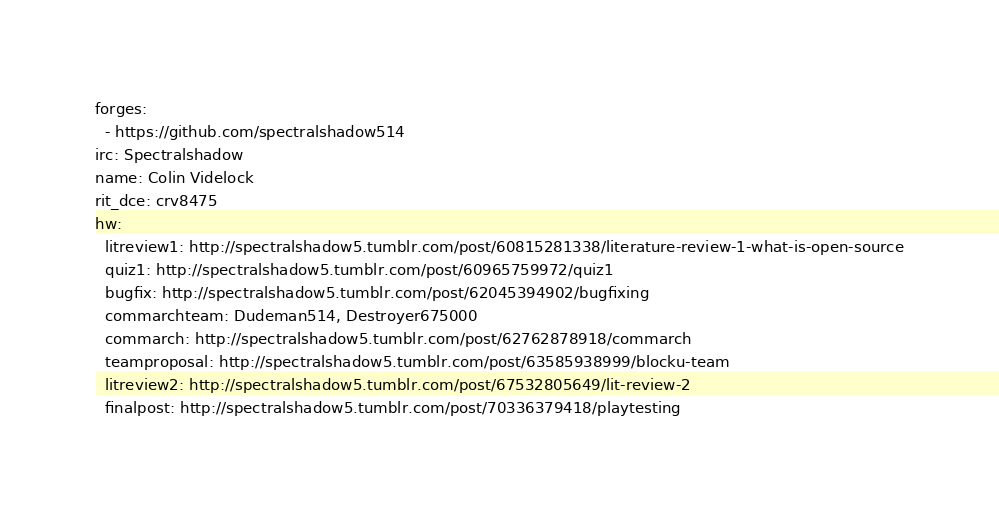<code> <loc_0><loc_0><loc_500><loc_500><_YAML_>forges:
  - https://github.com/spectralshadow514
irc: Spectralshadow
name: Colin Videlock
rit_dce: crv8475
hw:
  litreview1: http://spectralshadow5.tumblr.com/post/60815281338/literature-review-1-what-is-open-source
  quiz1: http://spectralshadow5.tumblr.com/post/60965759972/quiz1
  bugfix: http://spectralshadow5.tumblr.com/post/62045394902/bugfixing
  commarchteam: Dudeman514, Destroyer675000
  commarch: http://spectralshadow5.tumblr.com/post/62762878918/commarch
  teamproposal: http://spectralshadow5.tumblr.com/post/63585938999/blocku-team
  litreview2: http://spectralshadow5.tumblr.com/post/67532805649/lit-review-2
  finalpost: http://spectralshadow5.tumblr.com/post/70336379418/playtesting
</code> 